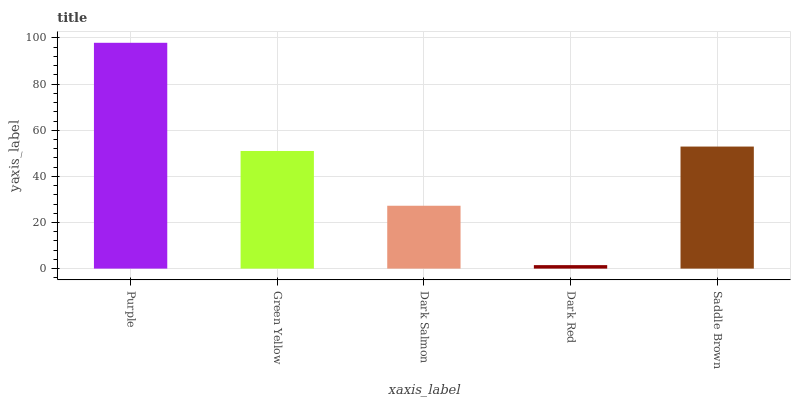Is Dark Red the minimum?
Answer yes or no. Yes. Is Purple the maximum?
Answer yes or no. Yes. Is Green Yellow the minimum?
Answer yes or no. No. Is Green Yellow the maximum?
Answer yes or no. No. Is Purple greater than Green Yellow?
Answer yes or no. Yes. Is Green Yellow less than Purple?
Answer yes or no. Yes. Is Green Yellow greater than Purple?
Answer yes or no. No. Is Purple less than Green Yellow?
Answer yes or no. No. Is Green Yellow the high median?
Answer yes or no. Yes. Is Green Yellow the low median?
Answer yes or no. Yes. Is Dark Red the high median?
Answer yes or no. No. Is Saddle Brown the low median?
Answer yes or no. No. 